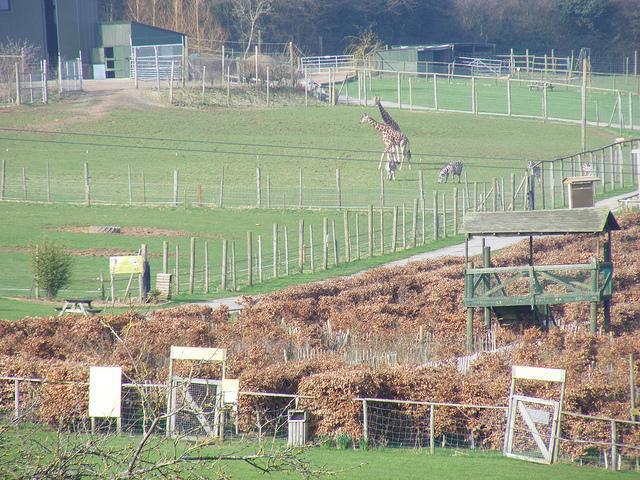How many bikes are there?
Give a very brief answer. 0. 